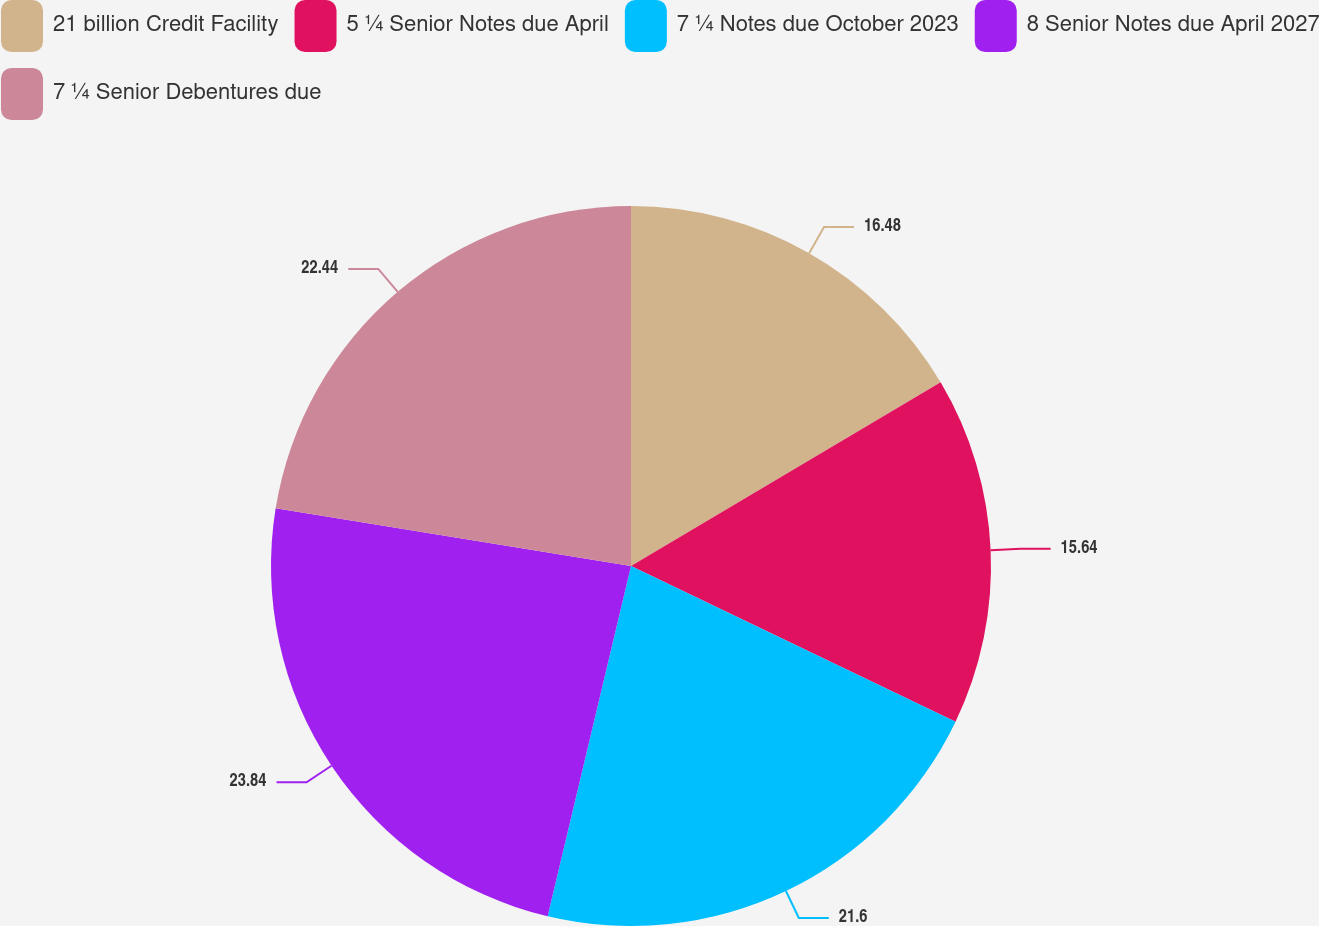<chart> <loc_0><loc_0><loc_500><loc_500><pie_chart><fcel>21 billion Credit Facility<fcel>5 ¼ Senior Notes due April<fcel>7 ¼ Notes due October 2023<fcel>8 Senior Notes due April 2027<fcel>7 ¼ Senior Debentures due<nl><fcel>16.48%<fcel>15.64%<fcel>21.6%<fcel>23.84%<fcel>22.44%<nl></chart> 